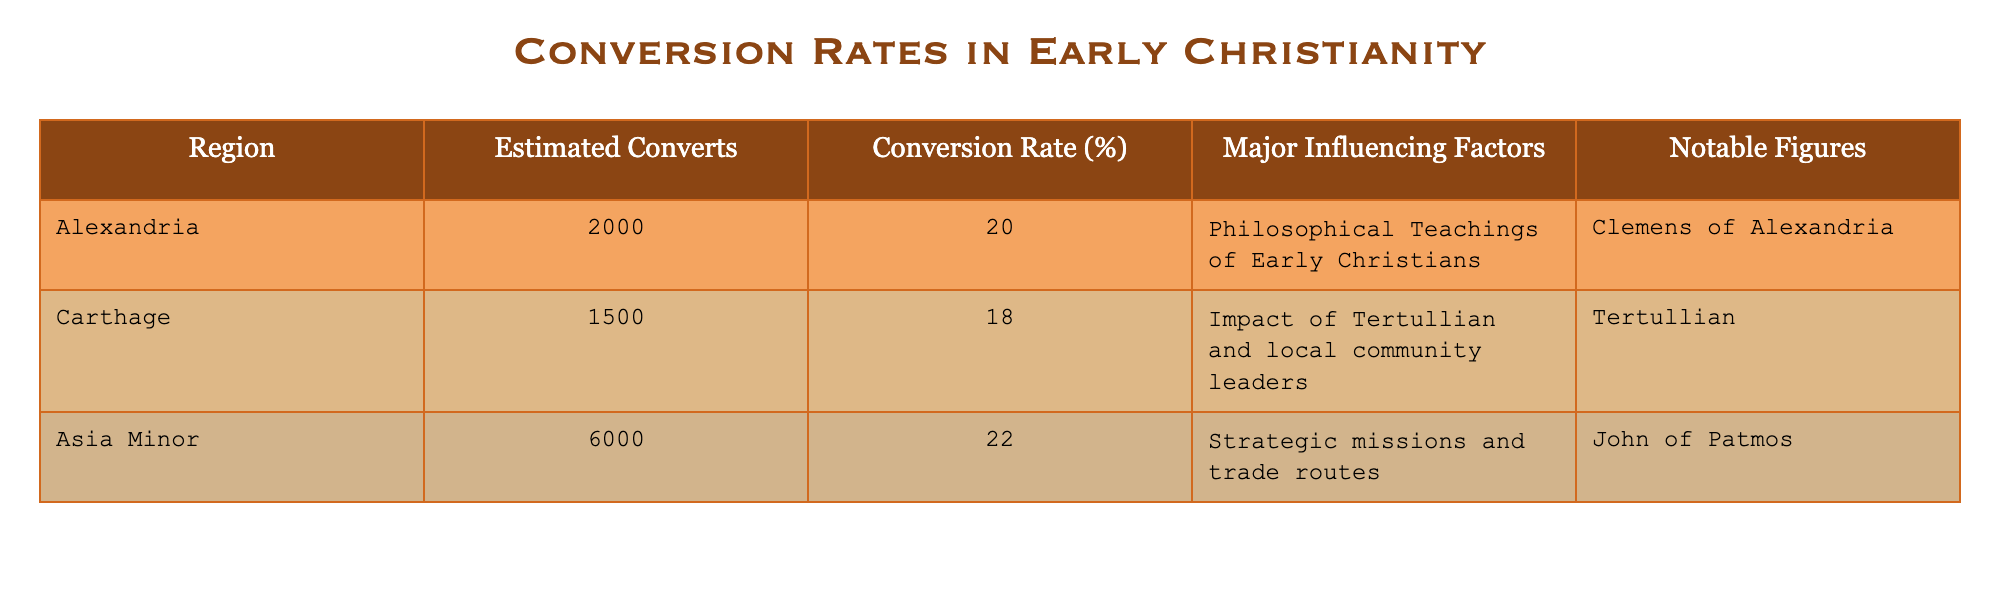What is the conversion rate for Alexandria? The conversion rate for Alexandria is listed directly in the table under the "Conversion Rate (%)" column, corresponding to the "Alexandria" row.
Answer: 20% How many estimated converts were there in Carthage? The estimated number of converts in Carthage is found in the "Estimated Converts" column, specifically the row for "Carthage."
Answer: 1500 Which region had the highest estimated converts? To determine the region with the highest estimated converts, compare the values in the "Estimated Converts" column. The maximum value is 6000 in the "Asia Minor" row.
Answer: Asia Minor Is Tertullian noted as a significant figure in the conversion of any region? Tertullian is noted under the "Notable Figures" column for the "Carthage" region, which implies he had a significant influence on conversions there.
Answer: Yes What is the average conversion rate across all regions listed? To determine the average conversion rate, add the conversion rates from all regions: (20 + 18 + 22) = 60. Then divide by the number of regions (3): 60/3 = 20.
Answer: 20% Which region's conversion rate is closest to the average? The average conversion rate calculated is 20%. The conversion rates for each region are 20% (Alexandria), 18% (Carthage), and 22% (Asia Minor). Here, Alexandria has the conversion rate equal to the average, while Carthage is below, and Asia Minor is above.
Answer: Alexandria What is the difference in estimated converts between Asia Minor and Carthage? The estimated converts for Asia Minor is 6000 and for Carthage is 1500. Calculating the difference gives 6000 - 1500 = 4500.
Answer: 4500 Does the table provide any insights about philosophical influences in conversion rates? Yes, the table indicates that philosophical teachings of early Christians influenced conversions in Alexandria.
Answer: Yes Which region had a major influence due to strategic missions and trade routes? The table states that Asia Minor's conversion was influenced by strategic missions and trade routes as listed under the influencing factors.
Answer: Asia Minor 